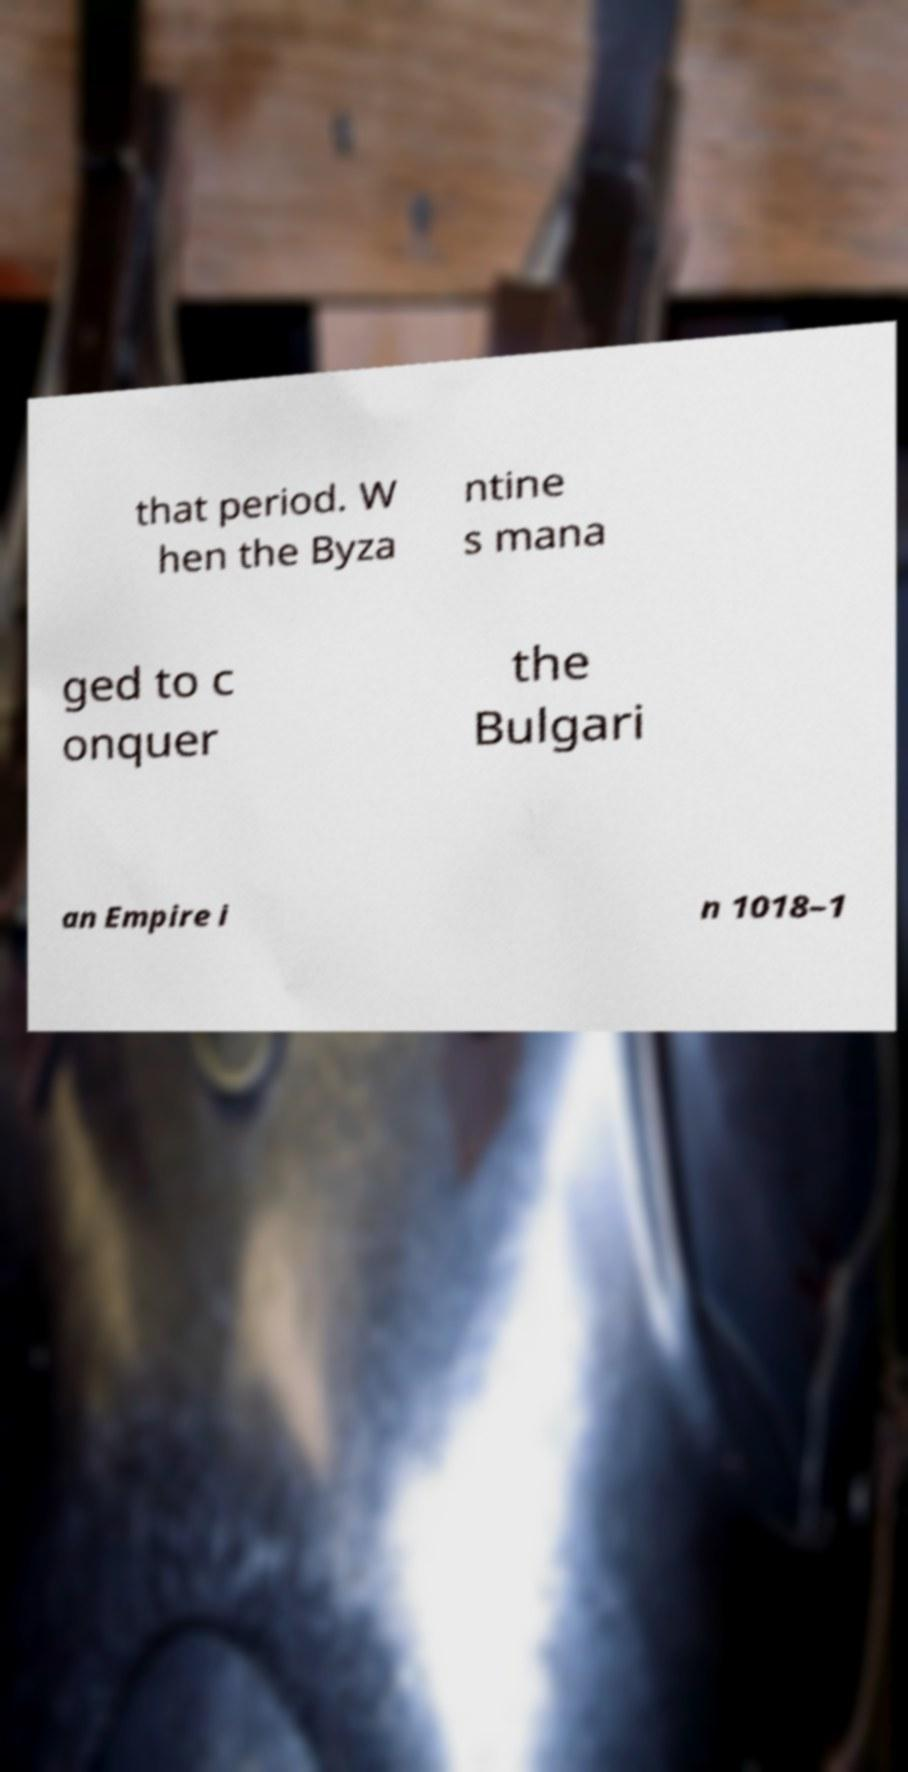Can you read and provide the text displayed in the image?This photo seems to have some interesting text. Can you extract and type it out for me? that period. W hen the Byza ntine s mana ged to c onquer the Bulgari an Empire i n 1018–1 